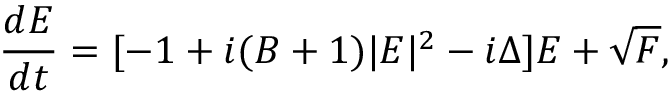Convert formula to latex. <formula><loc_0><loc_0><loc_500><loc_500>\frac { d E } { d t } = [ - 1 + i ( B + 1 ) | E | ^ { 2 } - i \Delta ] E + \sqrt { F } ,</formula> 